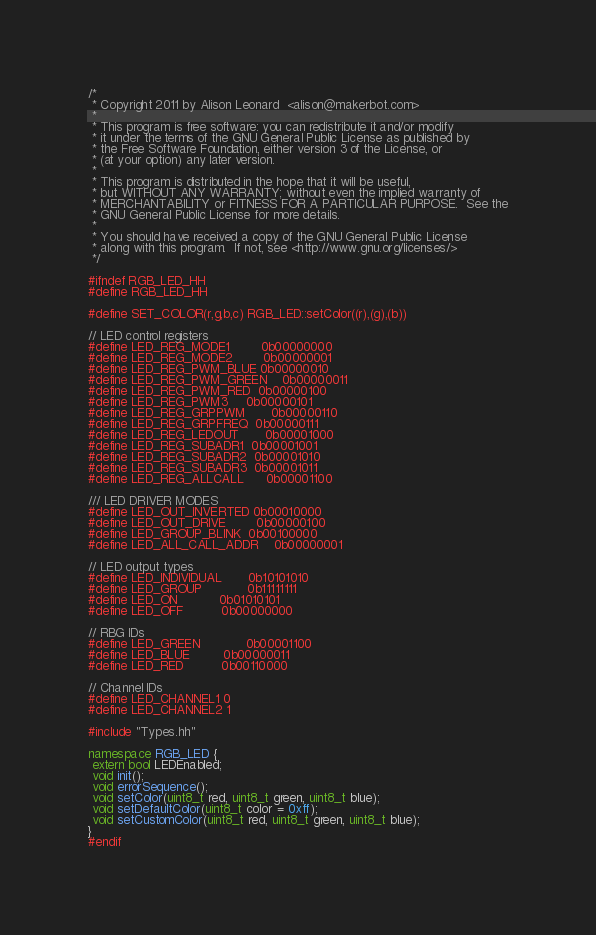<code> <loc_0><loc_0><loc_500><loc_500><_C++_>/*
 * Copyright 2011 by Alison Leonard	 <alison@makerbot.com>
 *
 * This program is free software: you can redistribute it and/or modify
 * it under the terms of the GNU General Public License as published by
 * the Free Software Foundation, either version 3 of the License, or
 * (at your option) any later version.
 *
 * This program is distributed in the hope that it will be useful,
 * but WITHOUT ANY WARRANTY; without even the implied warranty of
 * MERCHANTABILITY or FITNESS FOR A PARTICULAR PURPOSE.  See the
 * GNU General Public License for more details.
 *
 * You should have received a copy of the GNU General Public License
 * along with this program.  If not, see <http://www.gnu.org/licenses/>
 */

#ifndef RGB_LED_HH
#define RGB_LED_HH

#define SET_COLOR(r,g,b,c) RGB_LED::setColor((r),(g),(b))

// LED control registers
#define LED_REG_MODE1		0b00000000
#define LED_REG_MODE2		0b00000001
#define LED_REG_PWM_BLUE	0b00000010
#define LED_REG_PWM_GREEN	0b00000011
#define LED_REG_PWM_RED	0b00000100
#define LED_REG_PWM3		0b00000101
#define LED_REG_GRPPWM		0b00000110
#define LED_REG_GRPFREQ	0b00000111
#define LED_REG_LEDOUT		0b00001000
#define LED_REG_SUBADR1	0b00001001
#define LED_REG_SUBADR2	0b00001010
#define LED_REG_SUBADR3	0b00001011
#define LED_REG_ALLCALL  	0b00001100

/// LED DRIVER MODES
#define LED_OUT_INVERTED	0b00010000
#define LED_OUT_DRIVE		0b00000100
#define LED_GROUP_BLINK	0b00100000
#define LED_ALL_CALL_ADDR	0b00000001

// LED output types
#define LED_INDIVIDUAL		0b10101010
#define LED_GROUP		 	0b11111111
#define LED_ON 			0b01010101
#define LED_OFF			0b00000000

// RBG IDs
#define LED_GREEN 			0b00001100
#define LED_BLUE			0b00000011
#define LED_RED 			0b00110000

// Channel IDs
#define LED_CHANNEL1	0
#define LED_CHANNEL2	1

#include "Types.hh"

namespace RGB_LED {
 extern bool LEDEnabled;
 void init();
 void errorSequence();
 void setColor(uint8_t red, uint8_t green, uint8_t blue);
 void setDefaultColor(uint8_t color = 0xff);
 void setCustomColor(uint8_t red, uint8_t green, uint8_t blue);
}
#endif
</code> 